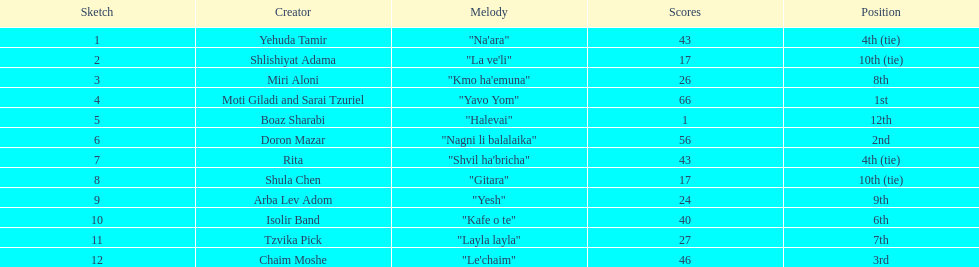What is the name of the song listed before the song "yesh"? "Gitara". 